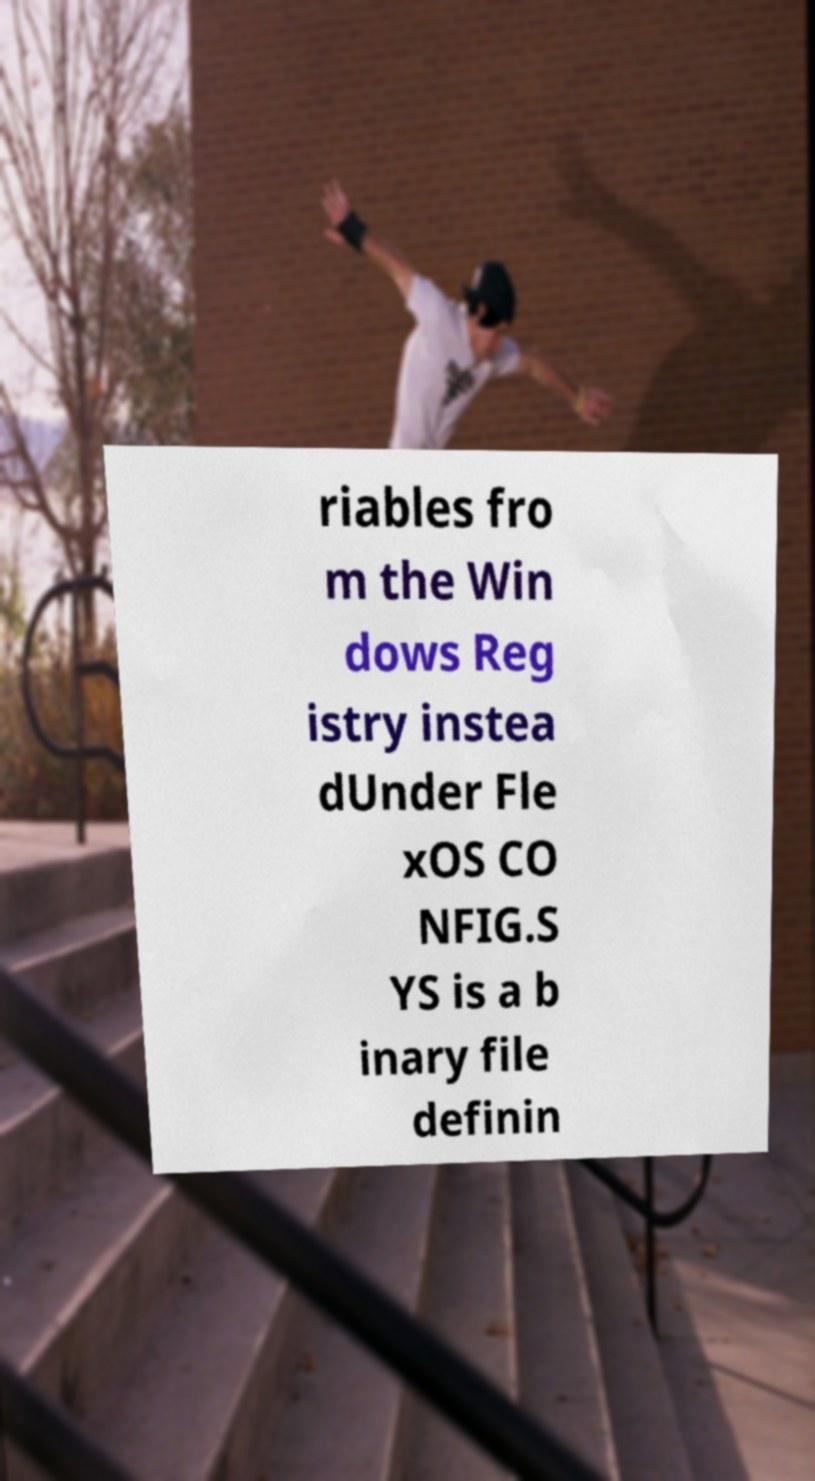Can you read and provide the text displayed in the image?This photo seems to have some interesting text. Can you extract and type it out for me? riables fro m the Win dows Reg istry instea dUnder Fle xOS CO NFIG.S YS is a b inary file definin 